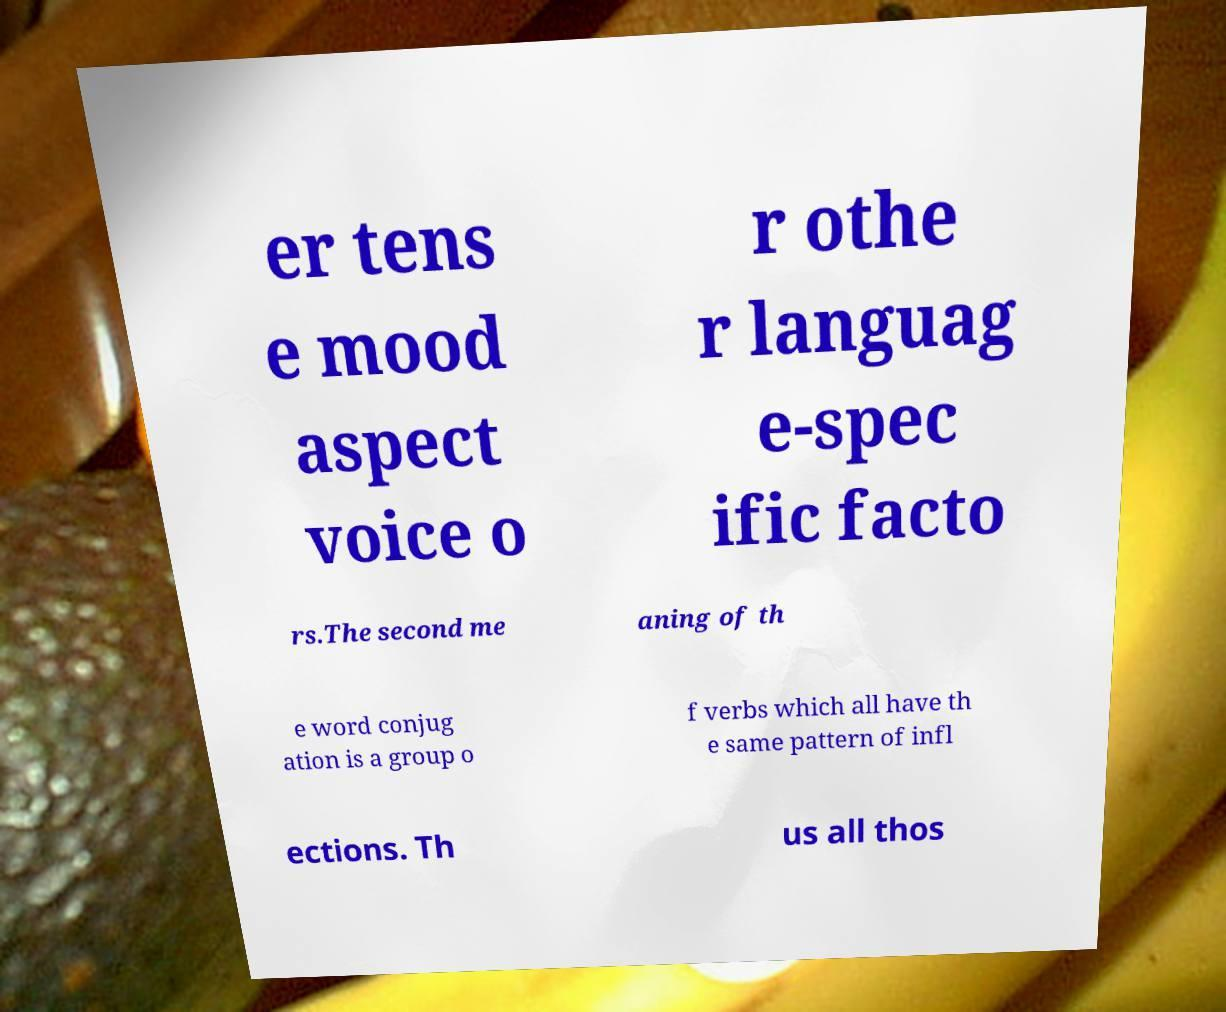Could you assist in decoding the text presented in this image and type it out clearly? er tens e mood aspect voice o r othe r languag e-spec ific facto rs.The second me aning of th e word conjug ation is a group o f verbs which all have th e same pattern of infl ections. Th us all thos 